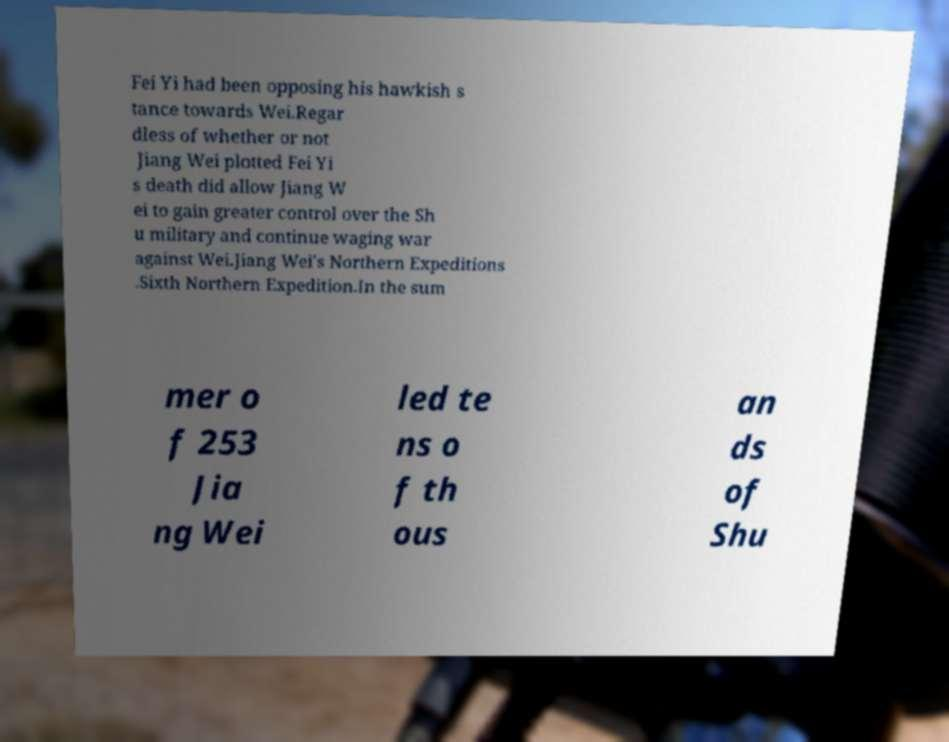Please read and relay the text visible in this image. What does it say? Fei Yi had been opposing his hawkish s tance towards Wei.Regar dless of whether or not Jiang Wei plotted Fei Yi s death did allow Jiang W ei to gain greater control over the Sh u military and continue waging war against Wei.Jiang Wei's Northern Expeditions .Sixth Northern Expedition.In the sum mer o f 253 Jia ng Wei led te ns o f th ous an ds of Shu 